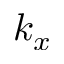Convert formula to latex. <formula><loc_0><loc_0><loc_500><loc_500>k _ { x }</formula> 